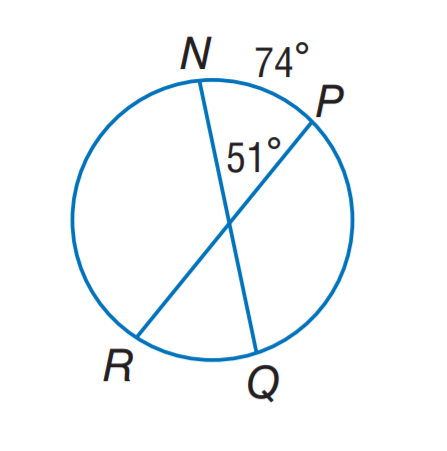Question: Find m \widehat R Q.
Choices:
A. 14
B. 28
C. 37
D. 51
Answer with the letter. Answer: B 